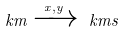<formula> <loc_0><loc_0><loc_500><loc_500>\ k m \xrightarrow { x , y } \ k m s</formula> 